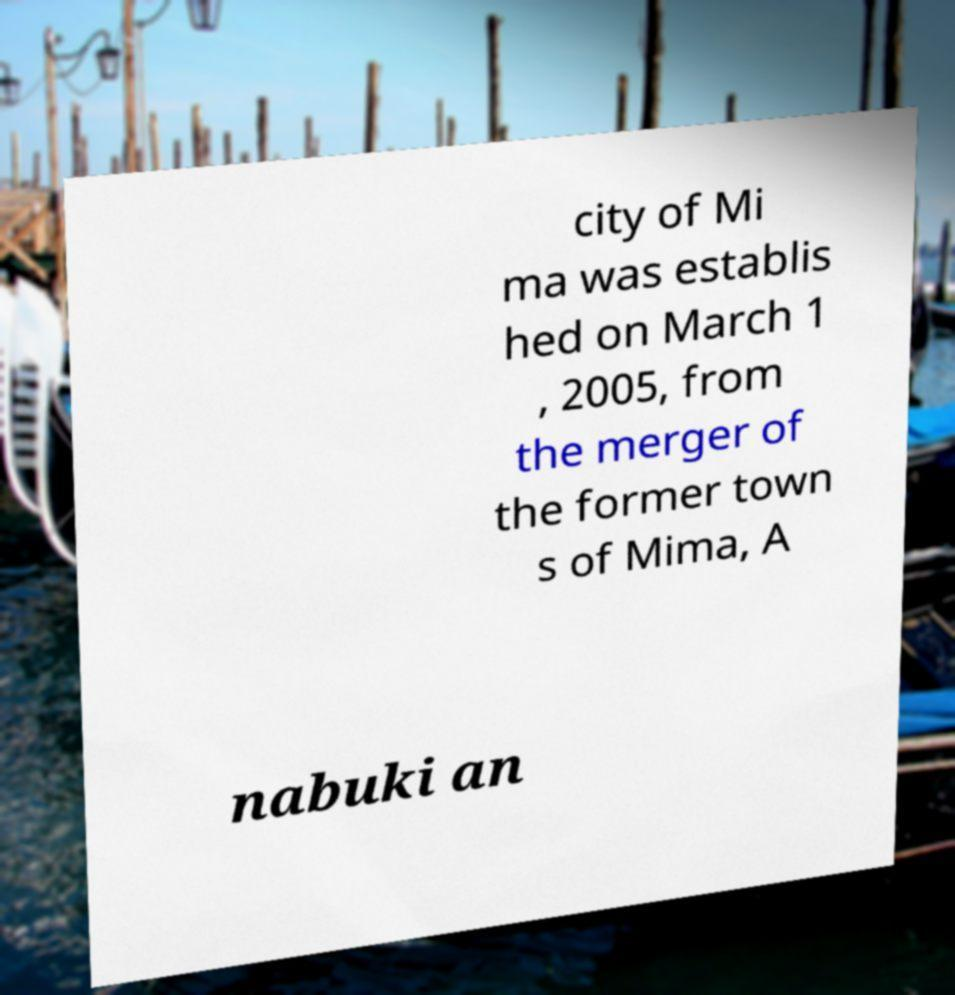For documentation purposes, I need the text within this image transcribed. Could you provide that? city of Mi ma was establis hed on March 1 , 2005, from the merger of the former town s of Mima, A nabuki an 